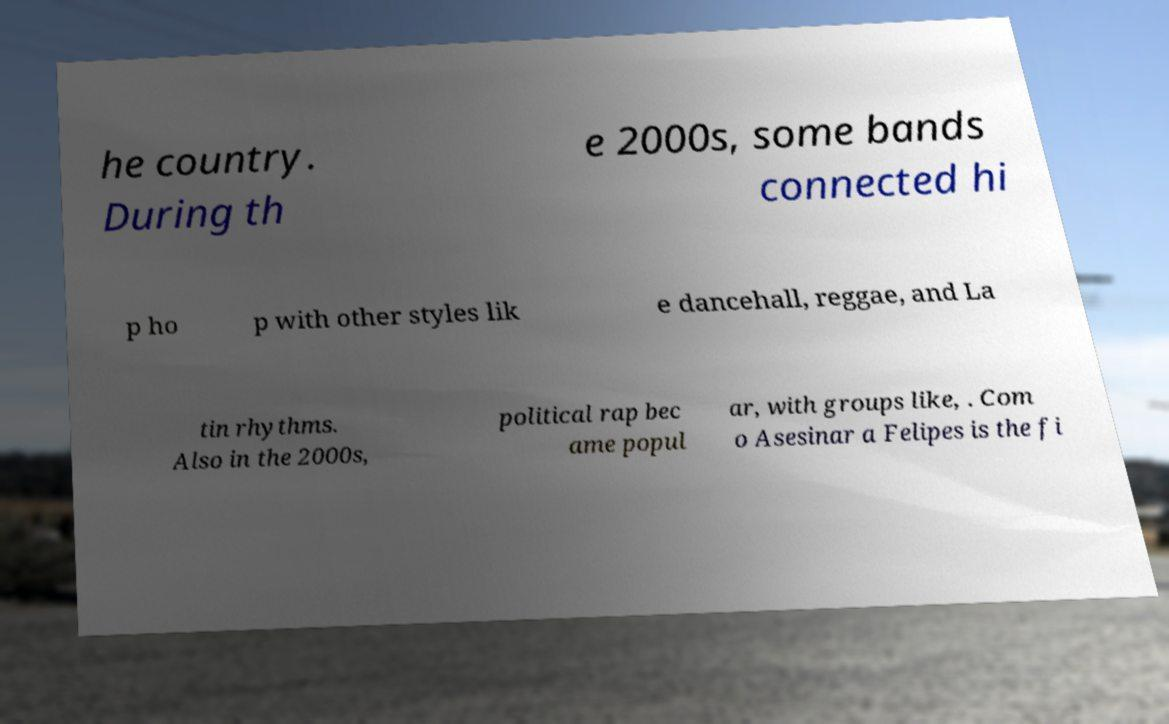For documentation purposes, I need the text within this image transcribed. Could you provide that? he country. During th e 2000s, some bands connected hi p ho p with other styles lik e dancehall, reggae, and La tin rhythms. Also in the 2000s, political rap bec ame popul ar, with groups like, . Com o Asesinar a Felipes is the fi 